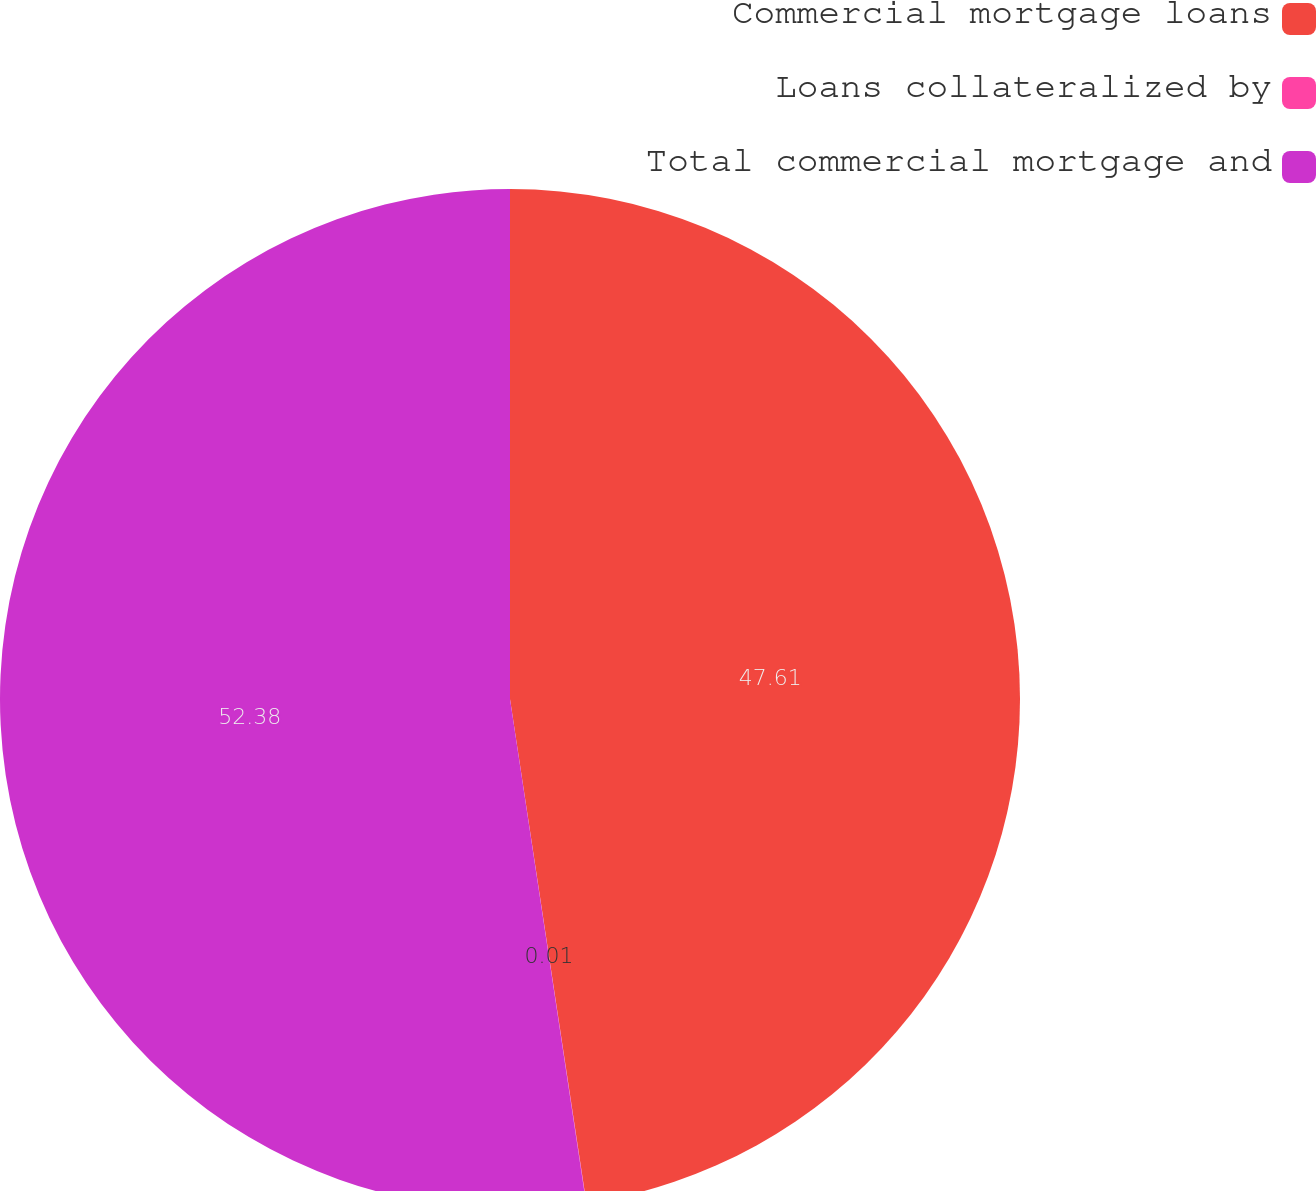Convert chart to OTSL. <chart><loc_0><loc_0><loc_500><loc_500><pie_chart><fcel>Commercial mortgage loans<fcel>Loans collateralized by<fcel>Total commercial mortgage and<nl><fcel>47.61%<fcel>0.01%<fcel>52.39%<nl></chart> 